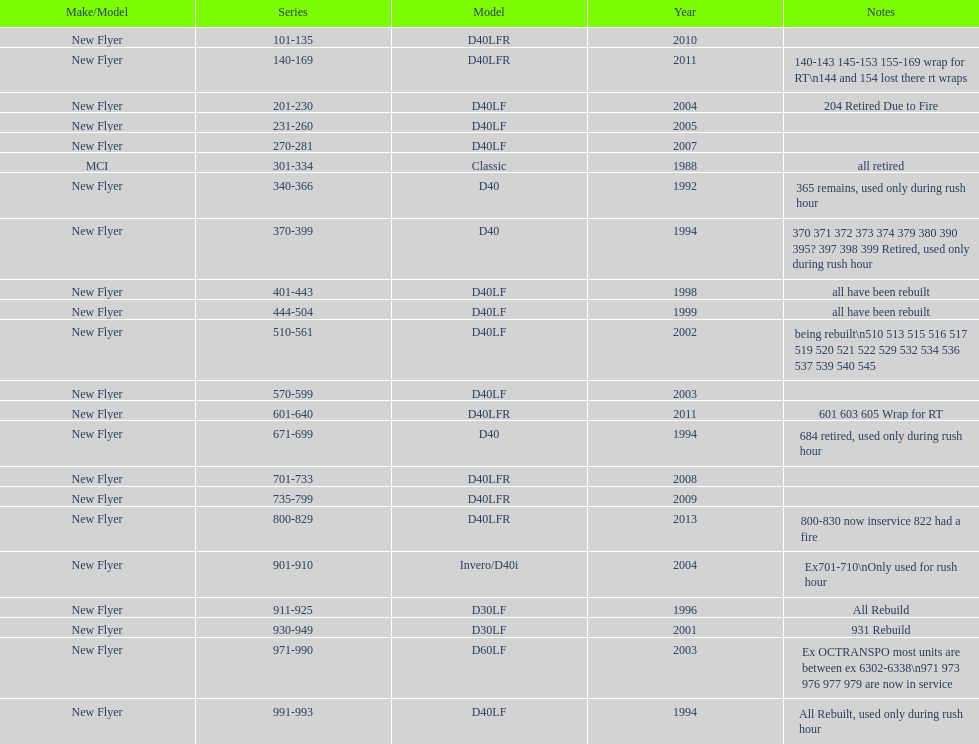Which buses are the newest in the current fleet? 800-829. 